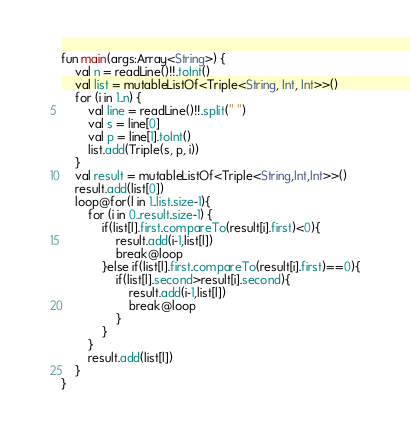<code> <loc_0><loc_0><loc_500><loc_500><_Kotlin_>fun main(args:Array<String>) {
    val n = readLine()!!.toInt()
    val list = mutableListOf<Triple<String, Int, Int>>()
    for (i in 1..n) {
        val line = readLine()!!.split(" ")
        val s = line[0]
        val p = line[1].toInt()
        list.add(Triple(s, p, i))
    }
    val result = mutableListOf<Triple<String,Int,Int>>()
    result.add(list[0])
    loop@for(l in 1..list.size-1){
        for (i in 0..result.size-1) {
            if(list[l].first.compareTo(result[i].first)<0){
                result.add(i-1,list[l])
                break@loop
            }else if(list[l].first.compareTo(result[i].first)==0){
                if(list[l].second>result[i].second){
                    result.add(i-1,list[l])
                    break@loop
                }
            }
        }
        result.add(list[l])
    }
}</code> 